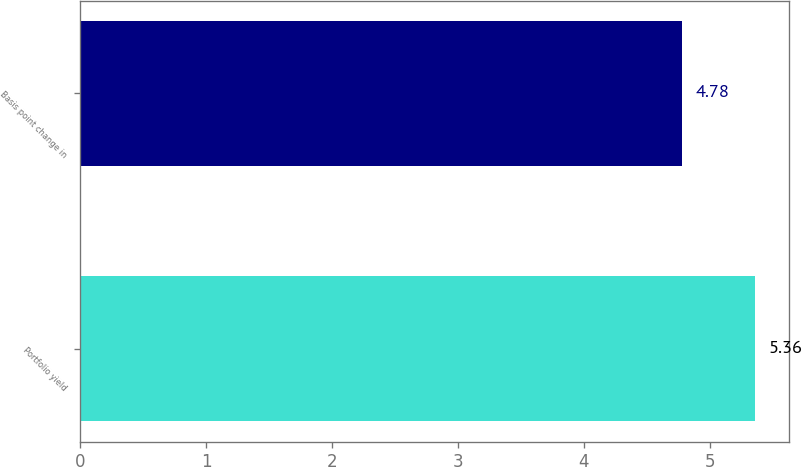<chart> <loc_0><loc_0><loc_500><loc_500><bar_chart><fcel>Portfolio yield<fcel>Basis point change in<nl><fcel>5.36<fcel>4.78<nl></chart> 